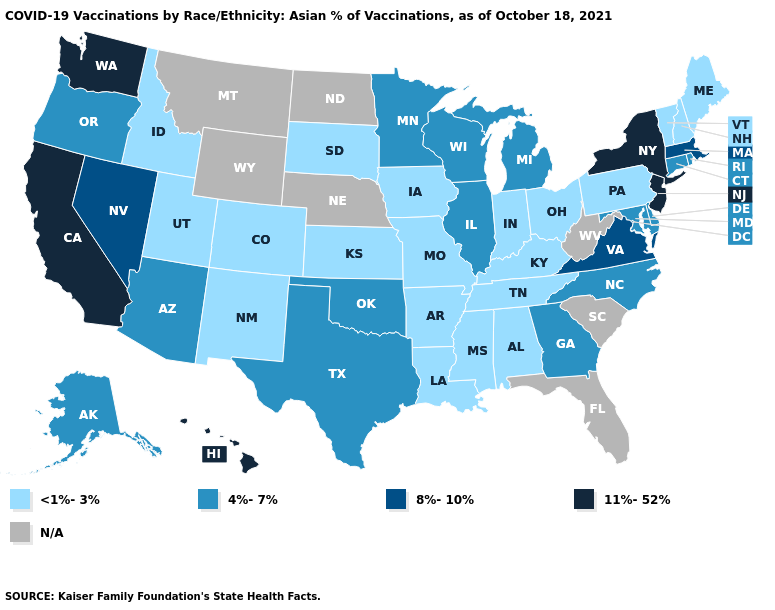Name the states that have a value in the range N/A?
Give a very brief answer. Florida, Montana, Nebraska, North Dakota, South Carolina, West Virginia, Wyoming. Does Louisiana have the lowest value in the South?
Be succinct. Yes. What is the lowest value in the USA?
Write a very short answer. <1%-3%. Which states hav the highest value in the MidWest?
Short answer required. Illinois, Michigan, Minnesota, Wisconsin. What is the highest value in the USA?
Answer briefly. 11%-52%. What is the value of Oklahoma?
Short answer required. 4%-7%. Among the states that border Indiana , which have the highest value?
Keep it brief. Illinois, Michigan. Name the states that have a value in the range N/A?
Give a very brief answer. Florida, Montana, Nebraska, North Dakota, South Carolina, West Virginia, Wyoming. Which states have the highest value in the USA?
Concise answer only. California, Hawaii, New Jersey, New York, Washington. Does Rhode Island have the highest value in the Northeast?
Keep it brief. No. Name the states that have a value in the range 8%-10%?
Be succinct. Massachusetts, Nevada, Virginia. Name the states that have a value in the range N/A?
Concise answer only. Florida, Montana, Nebraska, North Dakota, South Carolina, West Virginia, Wyoming. 